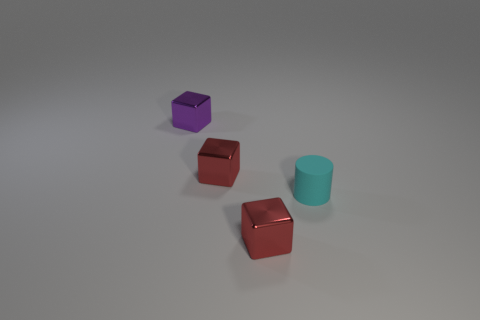The shiny cube on the right side of the red metal block left of the small shiny thing in front of the matte cylinder is what color?
Ensure brevity in your answer.  Red. What number of small shiny objects are in front of the tiny purple block and behind the tiny rubber cylinder?
Provide a succinct answer. 1. How many shiny objects are either cyan objects or brown things?
Your response must be concise. 0. There is a red cube that is behind the cube in front of the cyan cylinder; what is it made of?
Offer a terse response. Metal. What is the shape of the cyan rubber thing that is the same size as the purple metal block?
Make the answer very short. Cylinder. Are there fewer cyan objects than small blue blocks?
Provide a short and direct response. No. There is a red metal thing that is behind the small rubber object; is there a small metallic block that is behind it?
Offer a terse response. Yes. Is there any other thing of the same color as the small rubber object?
Provide a short and direct response. No. There is a shiny thing in front of the tiny cyan thing; does it have the same shape as the small cyan rubber object?
Your answer should be very brief. No. What number of other objects are the same shape as the purple metal object?
Make the answer very short. 2. 